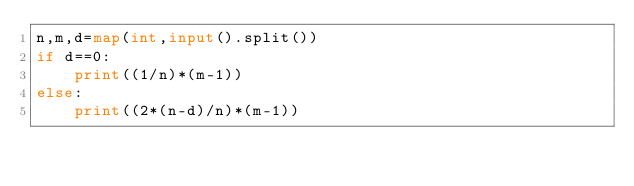<code> <loc_0><loc_0><loc_500><loc_500><_Python_>n,m,d=map(int,input().split())
if d==0:
    print((1/n)*(m-1))
else:
    print((2*(n-d)/n)*(m-1))</code> 